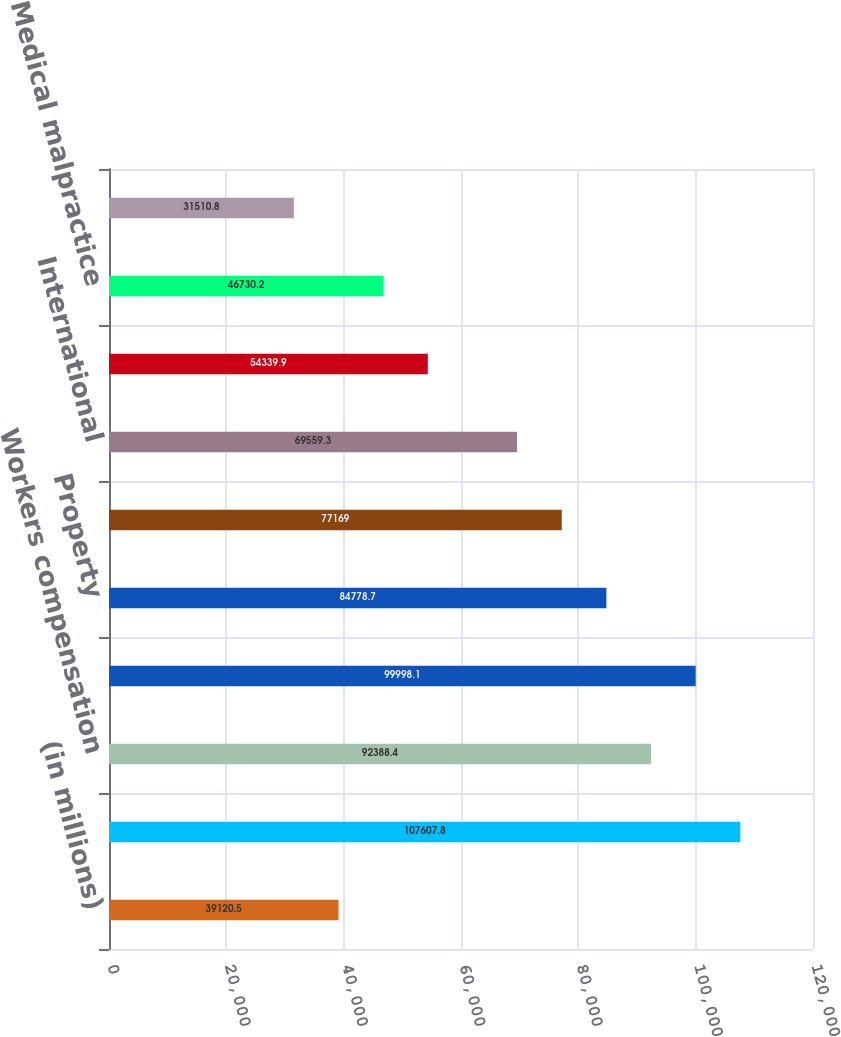Convert chart to OTSL. <chart><loc_0><loc_0><loc_500><loc_500><bar_chart><fcel>(in millions)<fcel>Other liability occurrence<fcel>Workers compensation<fcel>Other liability claims made<fcel>Property<fcel>Auto liability<fcel>International<fcel>Reinsurance<fcel>Medical malpractice<fcel>Products liability<nl><fcel>39120.5<fcel>107608<fcel>92388.4<fcel>99998.1<fcel>84778.7<fcel>77169<fcel>69559.3<fcel>54339.9<fcel>46730.2<fcel>31510.8<nl></chart> 